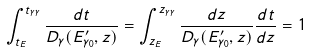<formula> <loc_0><loc_0><loc_500><loc_500>\int _ { t _ { E } } ^ { t _ { \gamma \gamma } } \frac { d t } { D _ { \gamma } ( E _ { \gamma _ { 0 } } ^ { \prime } , z ) } = \int _ { z _ { E } } ^ { z _ { \gamma \gamma } } \frac { d z } { D _ { \gamma } ( E _ { \gamma _ { 0 } } ^ { \prime } , z ) } \frac { d t } { d z } = 1</formula> 